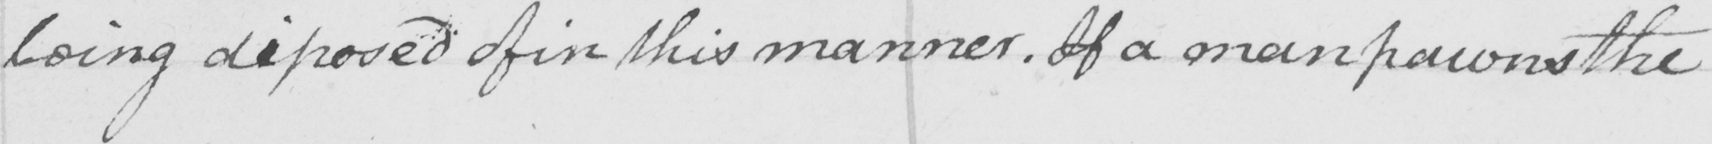What text is written in this handwritten line? being disposed of in this manner . If a man pawns the 